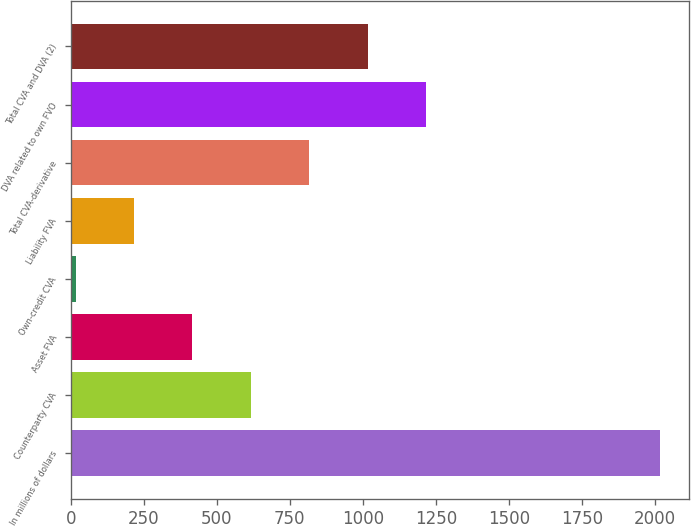Convert chart. <chart><loc_0><loc_0><loc_500><loc_500><bar_chart><fcel>In millions of dollars<fcel>Counterparty CVA<fcel>Asset FVA<fcel>Own-credit CVA<fcel>Liability FVA<fcel>Total CVA-derivative<fcel>DVA related to own FVO<fcel>Total CVA and DVA (2)<nl><fcel>2016<fcel>616.7<fcel>416.8<fcel>17<fcel>216.9<fcel>816.6<fcel>1216.4<fcel>1016.5<nl></chart> 